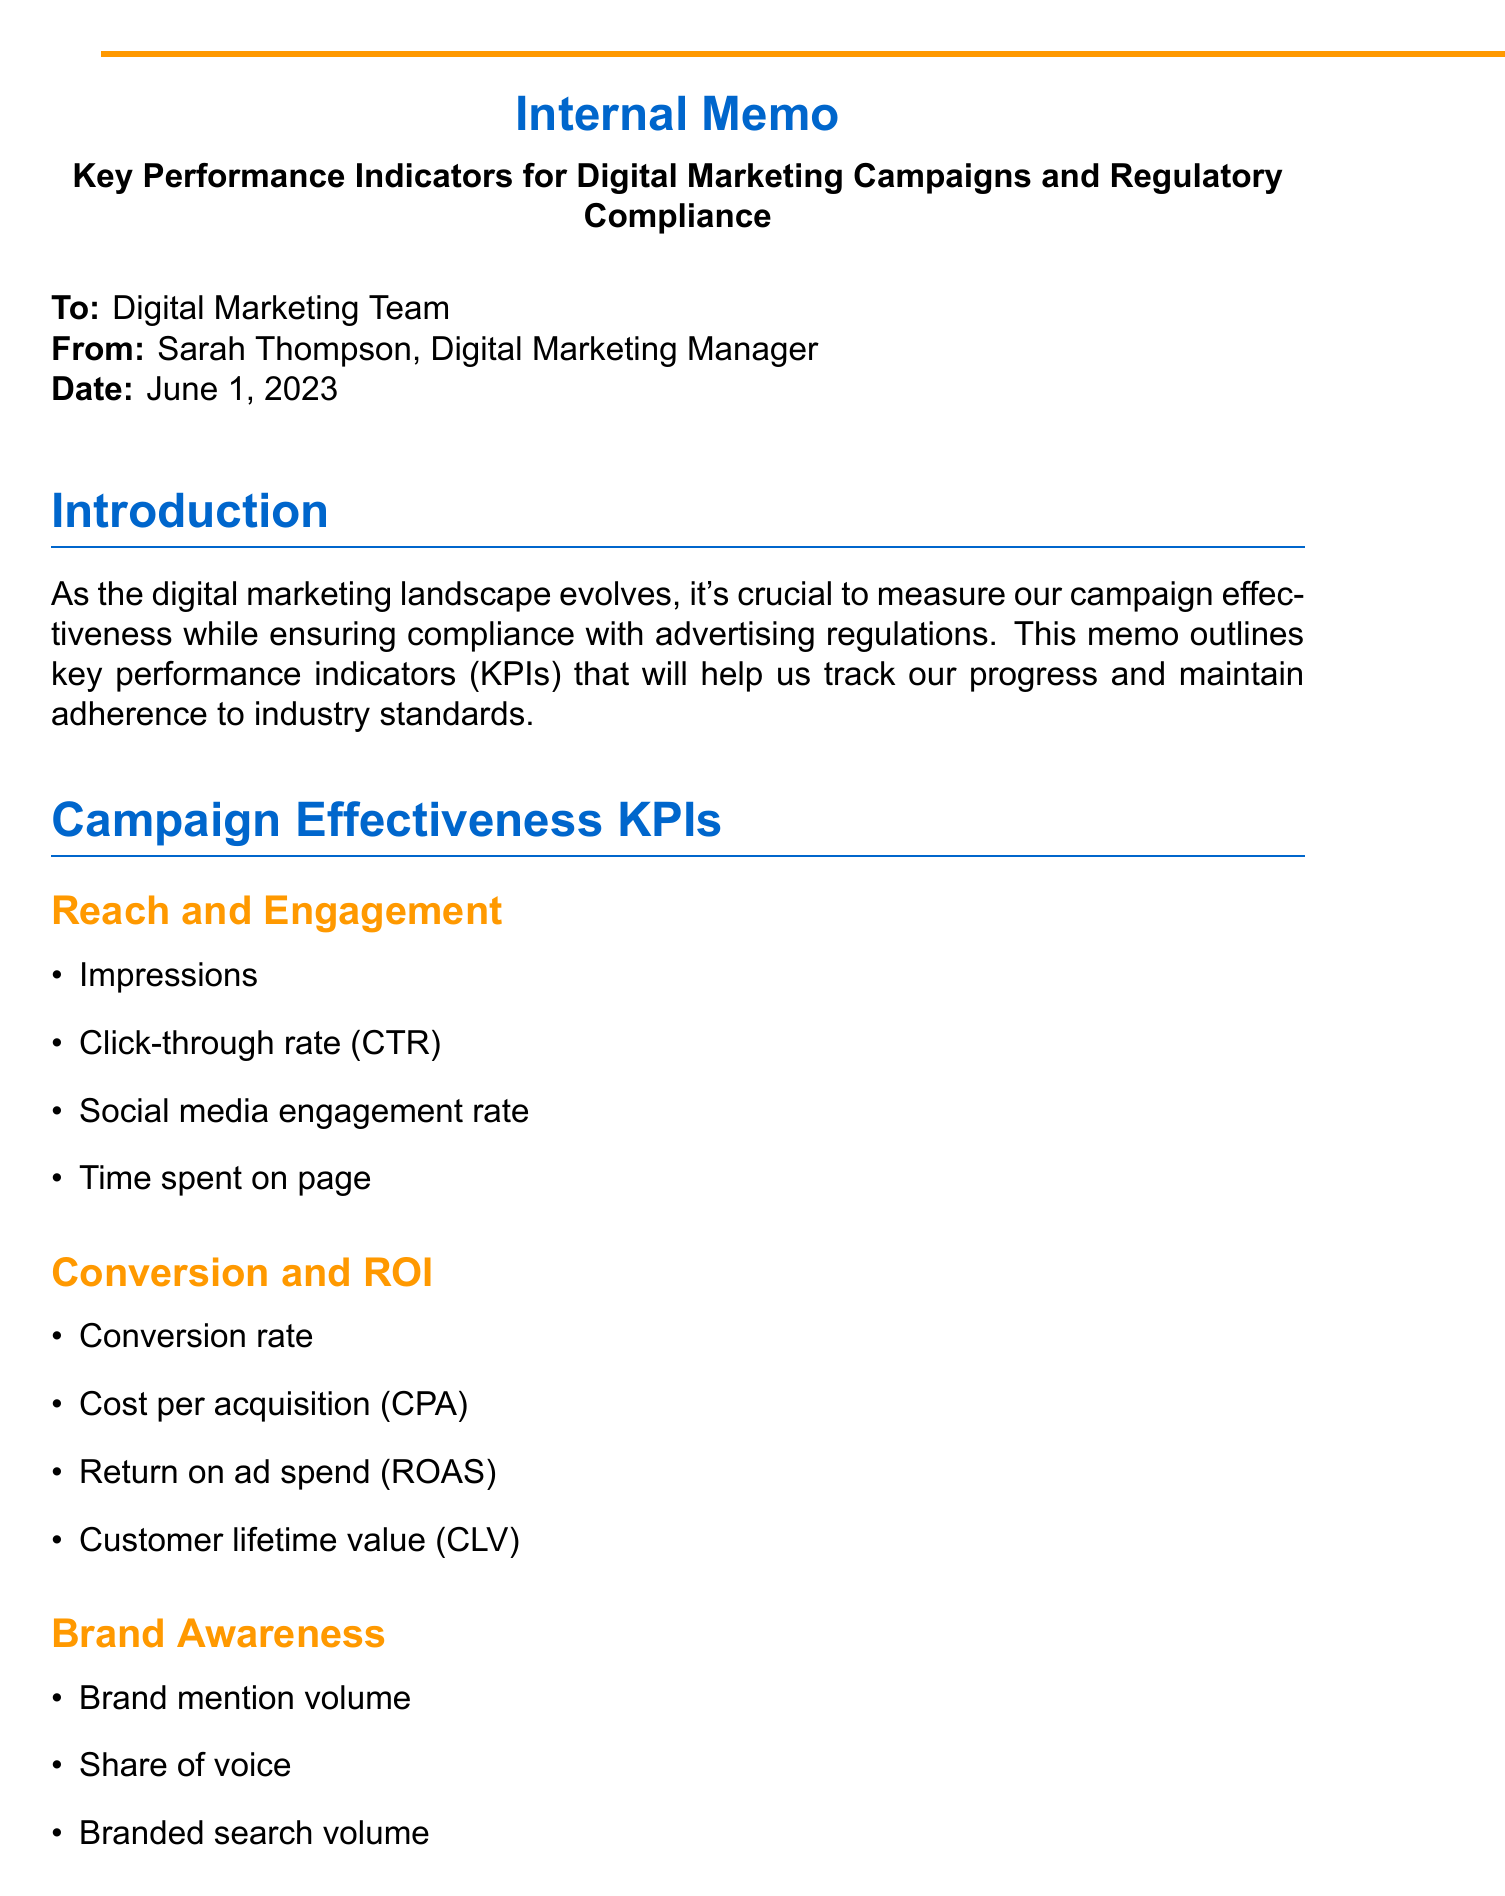What is the memo title? The title of the memo is clearly stated at the beginning of the document, which is "Key Performance Indicators for Digital Marketing Campaigns and Regulatory Compliance."
Answer: Key Performance Indicators for Digital Marketing Campaigns and Regulatory Compliance Who is the sender of the memo? The sender's name and title are provided in the header of the memo, which states Sarah Thompson as the Digital Marketing Manager.
Answer: Sarah Thompson What are the tools listed for tracking KPIs? The document explicitly lists the tools we will utilize to track KPIs, including Google Analytics and others.
Answer: Google Analytics, Hootsuite, SEMrush, OneTrust, Adobe Experience Platform What is the deadline for setting up custom reports in Google Analytics? The memo outlines specific action items with deadlines, specifically mentioning June 15 for setting up custom reports.
Answer: June 15 How often will reports be generated? The document mentions the frequency of report generation, stating monthly reports will be created.
Answer: Monthly What compliance regulation is mentioned under Data Privacy? The KPIs section regarding Data Privacy includes specific regulations that we need to comply with, such as GDPR.
Answer: GDPR How many campaign landing pages will be audited for accessibility? The action items section specifies conducting an audit of the top 10 campaign landing pages for accessibility.
Answer: 10 What is the purpose of the quarterly reviews? The document states that quarterly reviews are intended to ensure compliance and identify areas for improvement.
Answer: Compliance and areas for improvement 